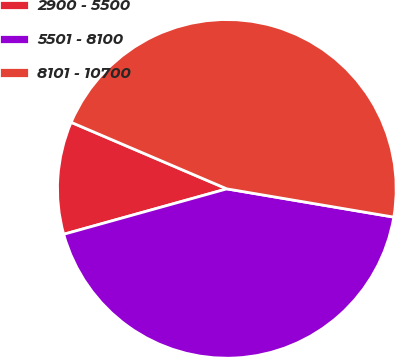Convert chart. <chart><loc_0><loc_0><loc_500><loc_500><pie_chart><fcel>2900 - 5500<fcel>5501 - 8100<fcel>8101 - 10700<nl><fcel>10.75%<fcel>43.01%<fcel>46.24%<nl></chart> 